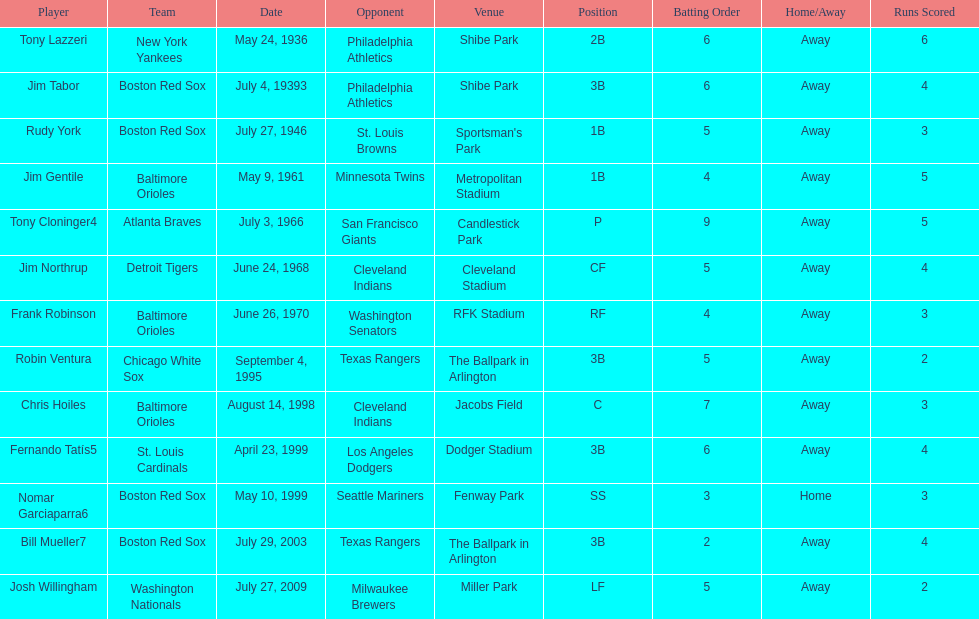What is the name of the player for the new york yankees in 1936? Tony Lazzeri. 